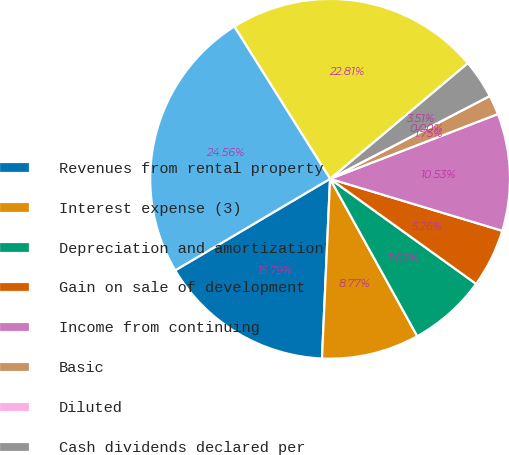<chart> <loc_0><loc_0><loc_500><loc_500><pie_chart><fcel>Revenues from rental property<fcel>Interest expense (3)<fcel>Depreciation and amortization<fcel>Gain on sale of development<fcel>Income from continuing<fcel>Basic<fcel>Diluted<fcel>Cash dividends declared per<fcel>depreciation<fcel>Total assets<nl><fcel>15.79%<fcel>8.77%<fcel>7.02%<fcel>5.26%<fcel>10.53%<fcel>1.75%<fcel>0.0%<fcel>3.51%<fcel>22.81%<fcel>24.56%<nl></chart> 